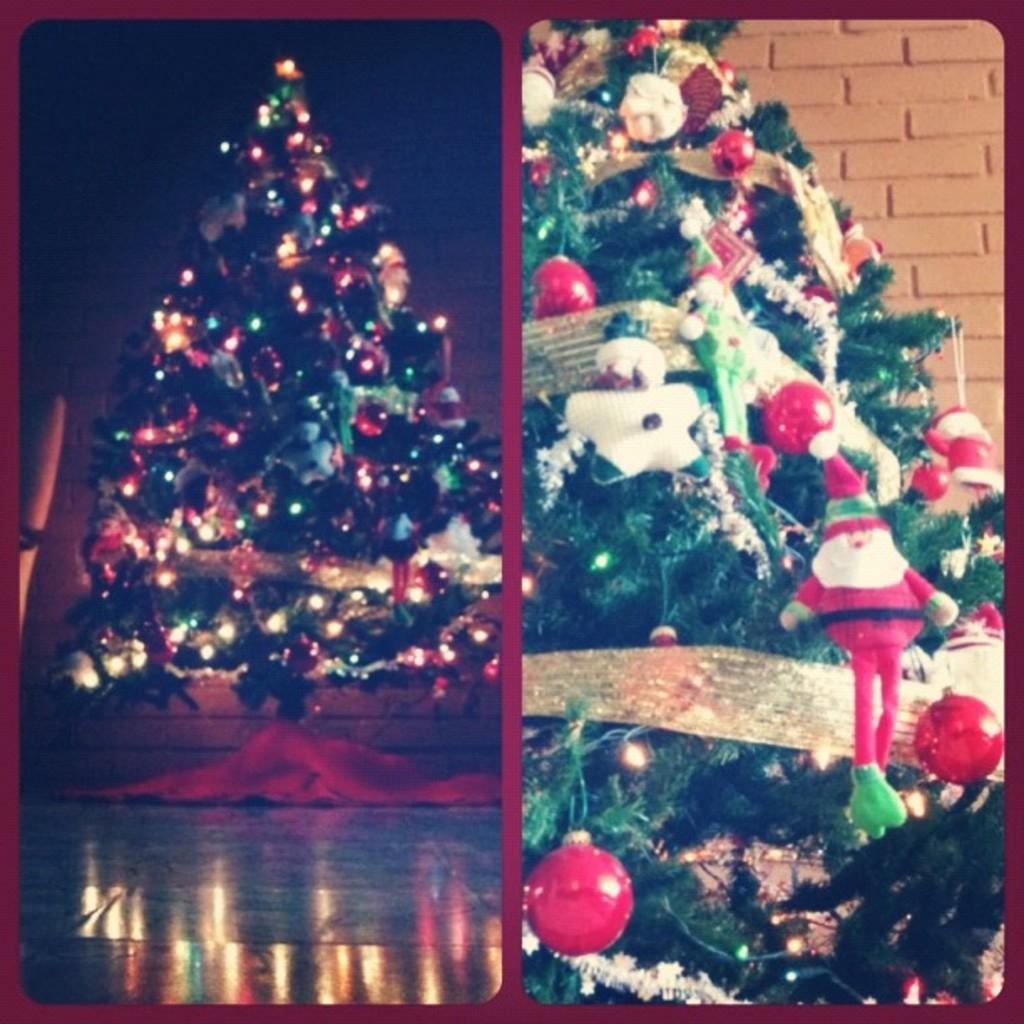What type of trees can be seen in the image? There are Christmas trees in the image. What else is present in the image besides the trees? There are lights and decorative items in the image. What is the acoustics like in the room where the Christmas trees are located? The provided facts do not mention any information about the acoustics in the room, so it cannot be determined from the image. 